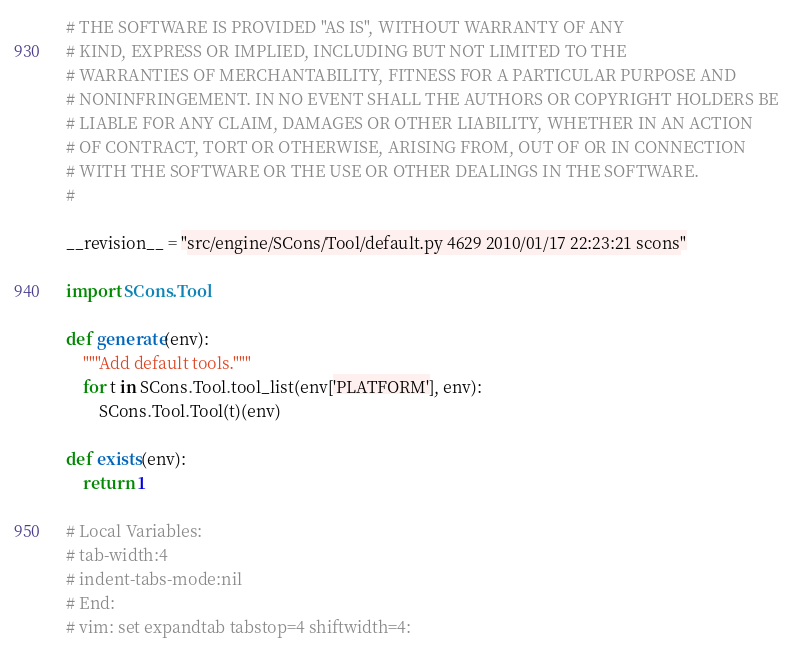Convert code to text. <code><loc_0><loc_0><loc_500><loc_500><_Python_># THE SOFTWARE IS PROVIDED "AS IS", WITHOUT WARRANTY OF ANY
# KIND, EXPRESS OR IMPLIED, INCLUDING BUT NOT LIMITED TO THE
# WARRANTIES OF MERCHANTABILITY, FITNESS FOR A PARTICULAR PURPOSE AND
# NONINFRINGEMENT. IN NO EVENT SHALL THE AUTHORS OR COPYRIGHT HOLDERS BE
# LIABLE FOR ANY CLAIM, DAMAGES OR OTHER LIABILITY, WHETHER IN AN ACTION
# OF CONTRACT, TORT OR OTHERWISE, ARISING FROM, OUT OF OR IN CONNECTION
# WITH THE SOFTWARE OR THE USE OR OTHER DEALINGS IN THE SOFTWARE.
#

__revision__ = "src/engine/SCons/Tool/default.py 4629 2010/01/17 22:23:21 scons"

import SCons.Tool

def generate(env):
    """Add default tools."""
    for t in SCons.Tool.tool_list(env['PLATFORM'], env):
        SCons.Tool.Tool(t)(env)

def exists(env):
    return 1

# Local Variables:
# tab-width:4
# indent-tabs-mode:nil
# End:
# vim: set expandtab tabstop=4 shiftwidth=4:
</code> 